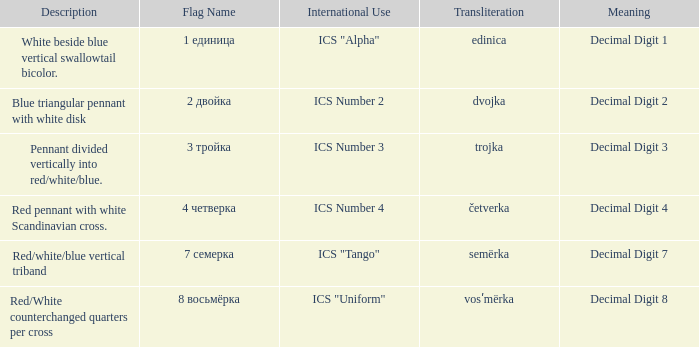What are the meanings of the flag whose name transliterates to dvojka? Decimal Digit 2. 